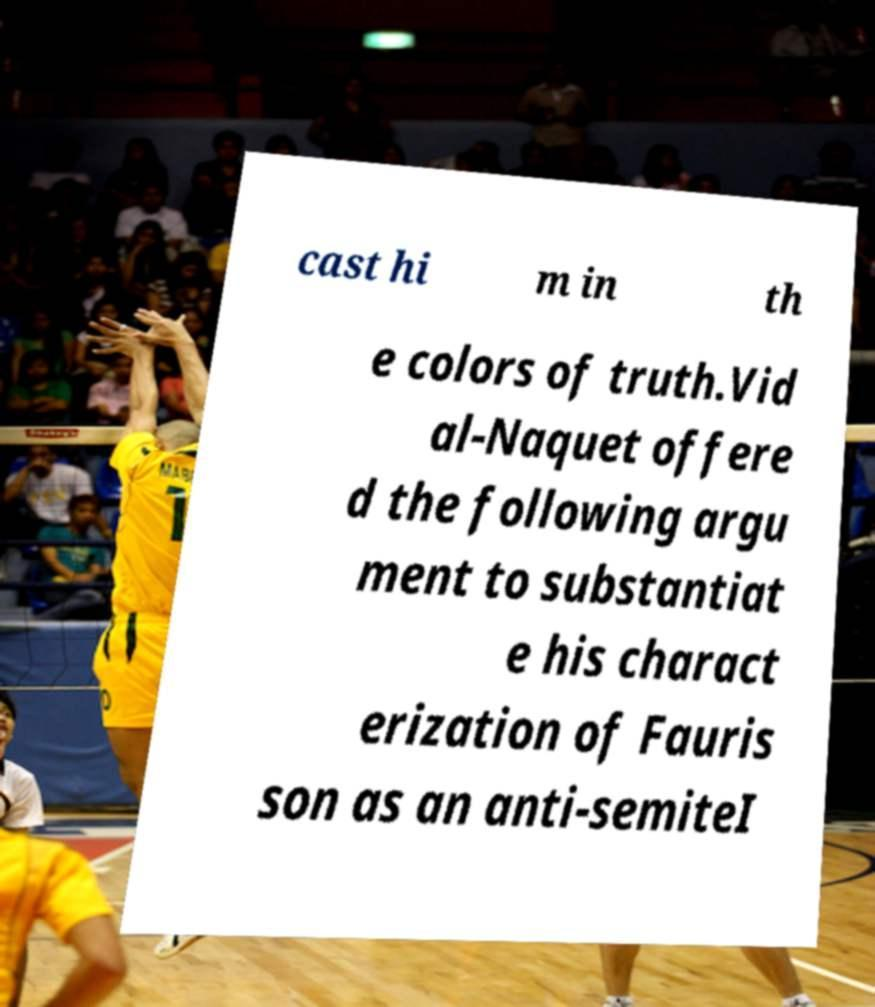Can you read and provide the text displayed in the image?This photo seems to have some interesting text. Can you extract and type it out for me? cast hi m in th e colors of truth.Vid al-Naquet offere d the following argu ment to substantiat e his charact erization of Fauris son as an anti-semiteI 